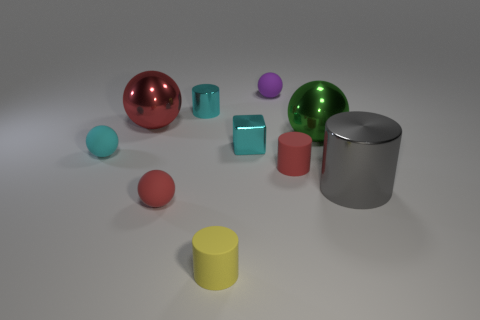Subtract all cyan balls. How many balls are left? 4 Subtract all cyan cylinders. How many red balls are left? 2 Subtract all green spheres. How many spheres are left? 4 Subtract 1 balls. How many balls are left? 4 Subtract all red cylinders. Subtract all green balls. How many cylinders are left? 3 Subtract all red metal objects. Subtract all tiny yellow spheres. How many objects are left? 9 Add 4 tiny purple rubber objects. How many tiny purple rubber objects are left? 5 Add 7 tiny yellow cylinders. How many tiny yellow cylinders exist? 8 Subtract 0 brown cylinders. How many objects are left? 10 Subtract all blocks. How many objects are left? 9 